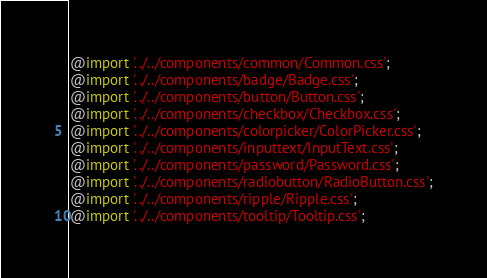<code> <loc_0><loc_0><loc_500><loc_500><_CSS_>@import '../../components/common/Common.css';
@import '../../components/badge/Badge.css';
@import '../../components/button/Button.css';
@import '../../components/checkbox/Checkbox.css';
@import '../../components/colorpicker/ColorPicker.css';
@import '../../components/inputtext/InputText.css';
@import '../../components/password/Password.css';
@import '../../components/radiobutton/RadioButton.css';
@import '../../components/ripple/Ripple.css';
@import '../../components/tooltip/Tooltip.css';</code> 